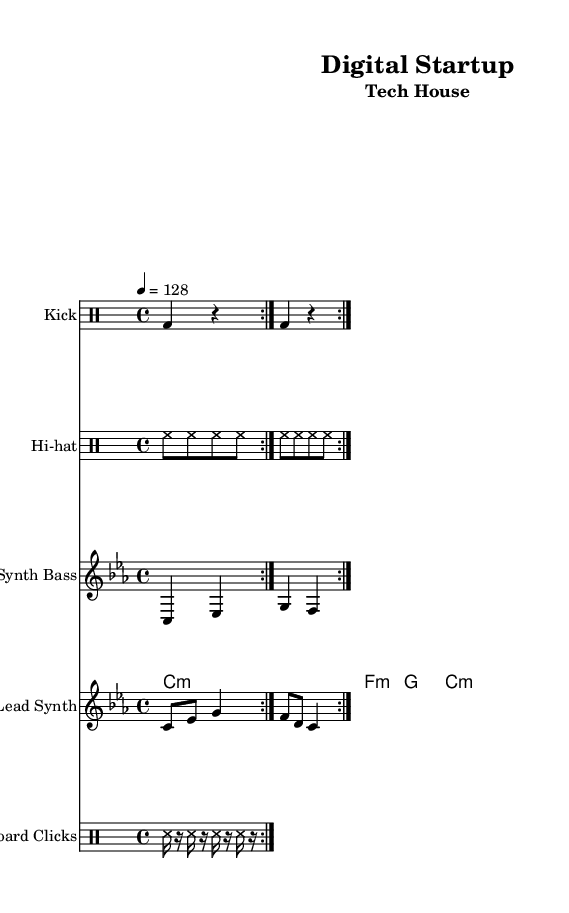What is the key signature of this music? The key signature shown is C minor, which has three flats (B♭, E♭, A♭) in the sheet music though the flats are not explicitly shown in the music.
Answer: C minor What is the time signature of this music? The time signature is located on the left side of the sheet music and it is written as 4/4, indicating four beats per measure.
Answer: 4/4 What is the tempo marking of this composition? The tempo marking indicates the speed of the music, which is set to quarter note equals 128 beats per minute.
Answer: 128 How many measures are in the kick pattern? The kick pattern is repeated in a volta of two, and the pattern shown consists of four measures, making a total of eight measures in the repeat.
Answer: 8 What type of instrument plays the lead synth? The lead synth is indicated on the staff and is classified as a synth, which is a common electronic instrument in tech house music.
Answer: Synth How many notes are in the synth bass sequence? The synth bass sequence shows a repeating pattern of four different notes: C, E♭, G, and F, counted over each measure, totaling eight notes when the cycle is repeated.
Answer: 8 What non-musical sound is included in the track? The sound of keyboard clicks is represented in the drum staff, demonstrating the tech house theme by incorporating these sound samples.
Answer: Keyboard clicks 